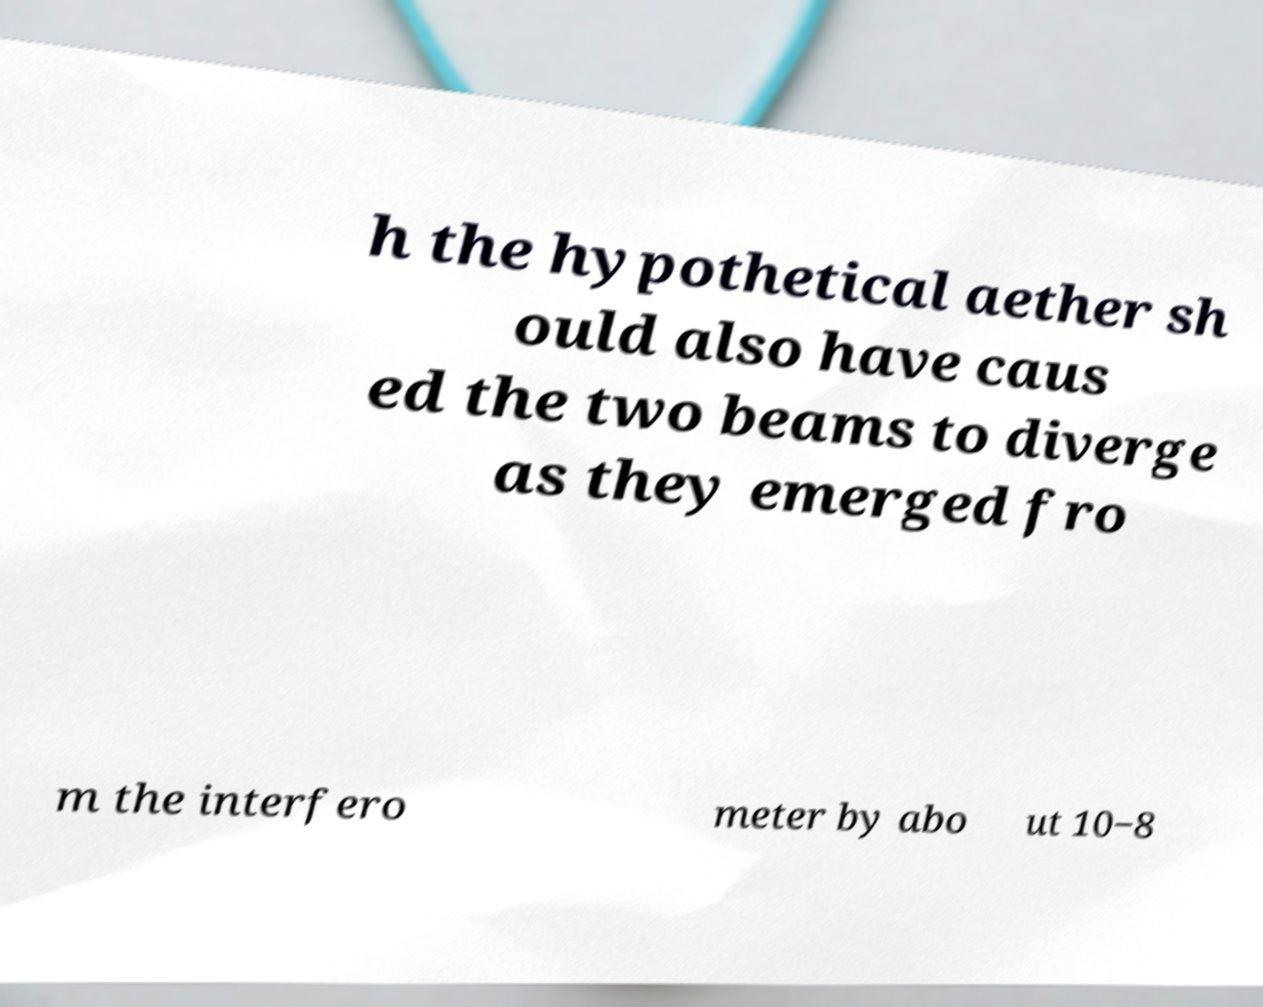I need the written content from this picture converted into text. Can you do that? h the hypothetical aether sh ould also have caus ed the two beams to diverge as they emerged fro m the interfero meter by abo ut 10−8 